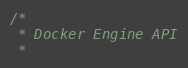<code> <loc_0><loc_0><loc_500><loc_500><_Rust_>/*
 * Docker Engine API
 *</code> 